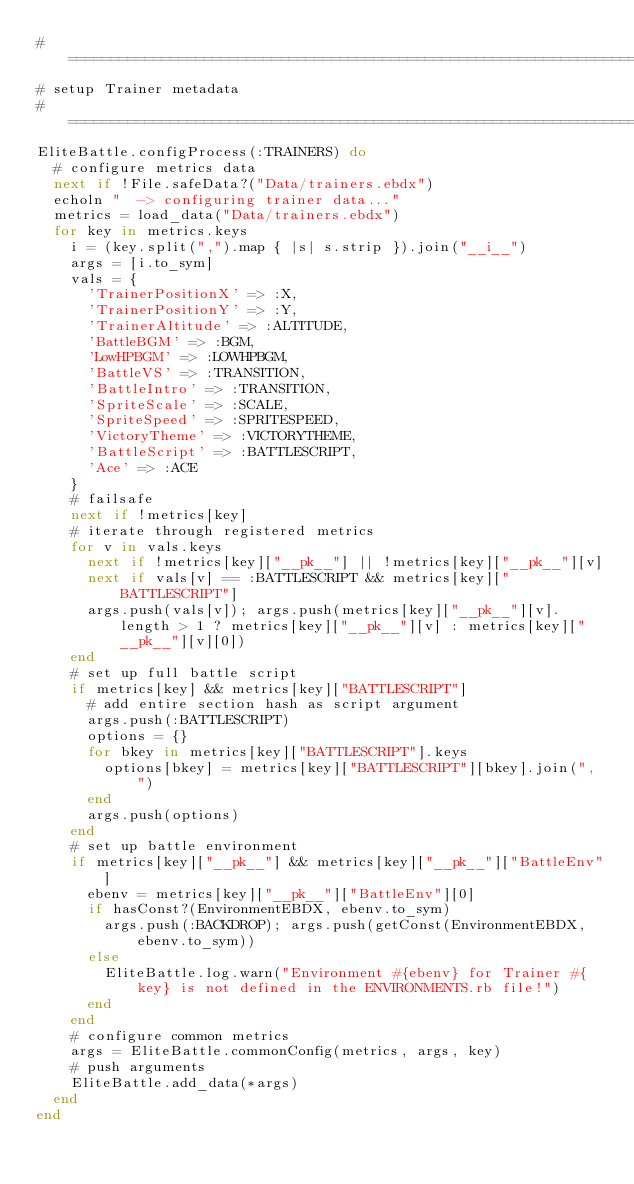<code> <loc_0><loc_0><loc_500><loc_500><_Ruby_>#===============================================================================
# setup Trainer metadata
#===============================================================================
EliteBattle.configProcess(:TRAINERS) do
  # configure metrics data
  next if !File.safeData?("Data/trainers.ebdx")
  echoln "  -> configuring trainer data..."
  metrics = load_data("Data/trainers.ebdx")
  for key in metrics.keys
    i = (key.split(",").map { |s| s.strip }).join("__i__")
    args = [i.to_sym]
    vals = {
      'TrainerPositionX' => :X,
      'TrainerPositionY' => :Y,
      'TrainerAltitude' => :ALTITUDE,
      'BattleBGM' => :BGM,
      'LowHPBGM' => :LOWHPBGM,
      'BattleVS' => :TRANSITION,
      'BattleIntro' => :TRANSITION,
      'SpriteScale' => :SCALE,
      'SpriteSpeed' => :SPRITESPEED,
      'VictoryTheme' => :VICTORYTHEME,
      'BattleScript' => :BATTLESCRIPT,
      'Ace' => :ACE
    }
    # failsafe
    next if !metrics[key]
    # iterate through registered metrics
    for v in vals.keys
      next if !metrics[key]["__pk__"] || !metrics[key]["__pk__"][v]
      next if vals[v] == :BATTLESCRIPT && metrics[key]["BATTLESCRIPT"]
      args.push(vals[v]); args.push(metrics[key]["__pk__"][v].length > 1 ? metrics[key]["__pk__"][v] : metrics[key]["__pk__"][v][0])
    end
    # set up full battle script
    if metrics[key] && metrics[key]["BATTLESCRIPT"]
      # add entire section hash as script argument
      args.push(:BATTLESCRIPT)
      options = {}
      for bkey in metrics[key]["BATTLESCRIPT"].keys
        options[bkey] = metrics[key]["BATTLESCRIPT"][bkey].join(", ")
      end
      args.push(options)
    end
    # set up battle environment
    if metrics[key]["__pk__"] && metrics[key]["__pk__"]["BattleEnv"]
      ebenv = metrics[key]["__pk__"]["BattleEnv"][0]
      if hasConst?(EnvironmentEBDX, ebenv.to_sym)
        args.push(:BACKDROP); args.push(getConst(EnvironmentEBDX, ebenv.to_sym))
      else
        EliteBattle.log.warn("Environment #{ebenv} for Trainer #{key} is not defined in the ENVIRONMENTS.rb file!")
      end
    end
    # configure common metrics
    args = EliteBattle.commonConfig(metrics, args, key)
    # push arguments
    EliteBattle.add_data(*args)
  end
end
</code> 